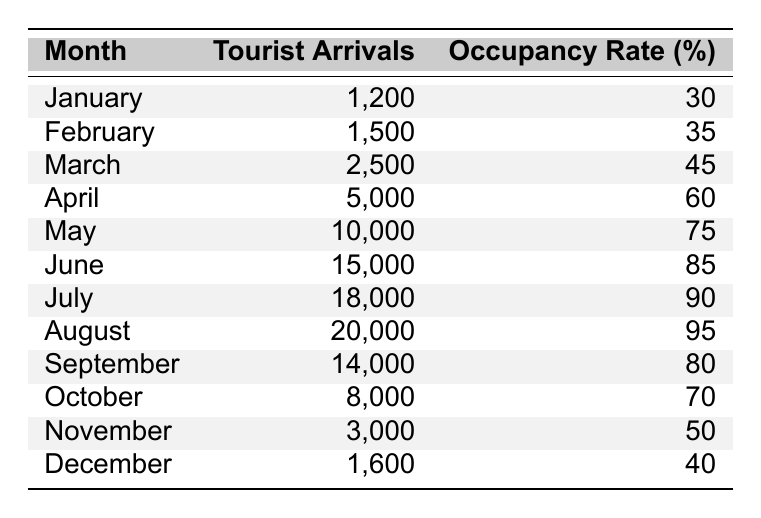What month had the highest number of tourist arrivals? In the table, we can see that August has the highest tourist arrivals with a total of 20,000.
Answer: August What was the accommodation occupancy rate in June? The table shows that in June, the accommodation occupancy rate was 85%.
Answer: 85% How many tourist arrivals were there in the first quarter (January to March)? To find the total arrivals, we add the arrivals in January (1,200), February (1,500), and March (2,500): 1,200 + 1,500 + 2,500 = 5,200.
Answer: 5,200 Which month had a higher occupancy rate, April or October? The occupancy rate for April is 60% and for October, it is 70%. Since 70% > 60%, October had a higher occupancy rate.
Answer: October What was the difference in tourist arrivals between July and September? For July, there were 18,000 tourist arrivals, and for September, there were 14,000. The difference is 18,000 - 14,000 = 4,000.
Answer: 4,000 What was the average occupancy rate from May to August? The occupancy rates for May (75%), June (85%), July (90%), and August (95%) are added together: 75 + 85 + 90 + 95 = 345. Then divide by 4 to find the average: 345 / 4 = 86.25.
Answer: 86.25 Did more tourists arrive in November compared to January? In November, there were 3,000 tourist arrivals, while in January, there were 1,200. Since 3,000 > 1,200, yes, more tourists arrived in November.
Answer: Yes How many total tourist arrivals were recorded from January to April? Adding the tourist arrivals from January (1,200), February (1,500), March (2,500), and April (5,000): 1,200 + 1,500 + 2,500 + 5,000 = 10,200.
Answer: 10,200 Which month has the lowest accommodation occupancy rate and what is the rate? From the table, January has the lowest occupancy rate of 30%.
Answer: January, 30% If we consider June to August, what is the total occupancy rate for these three months? The occupancy rates for June (85%), July (90%), and August (95%) can be summed up: 85 + 90 + 95 = 270.
Answer: 270 